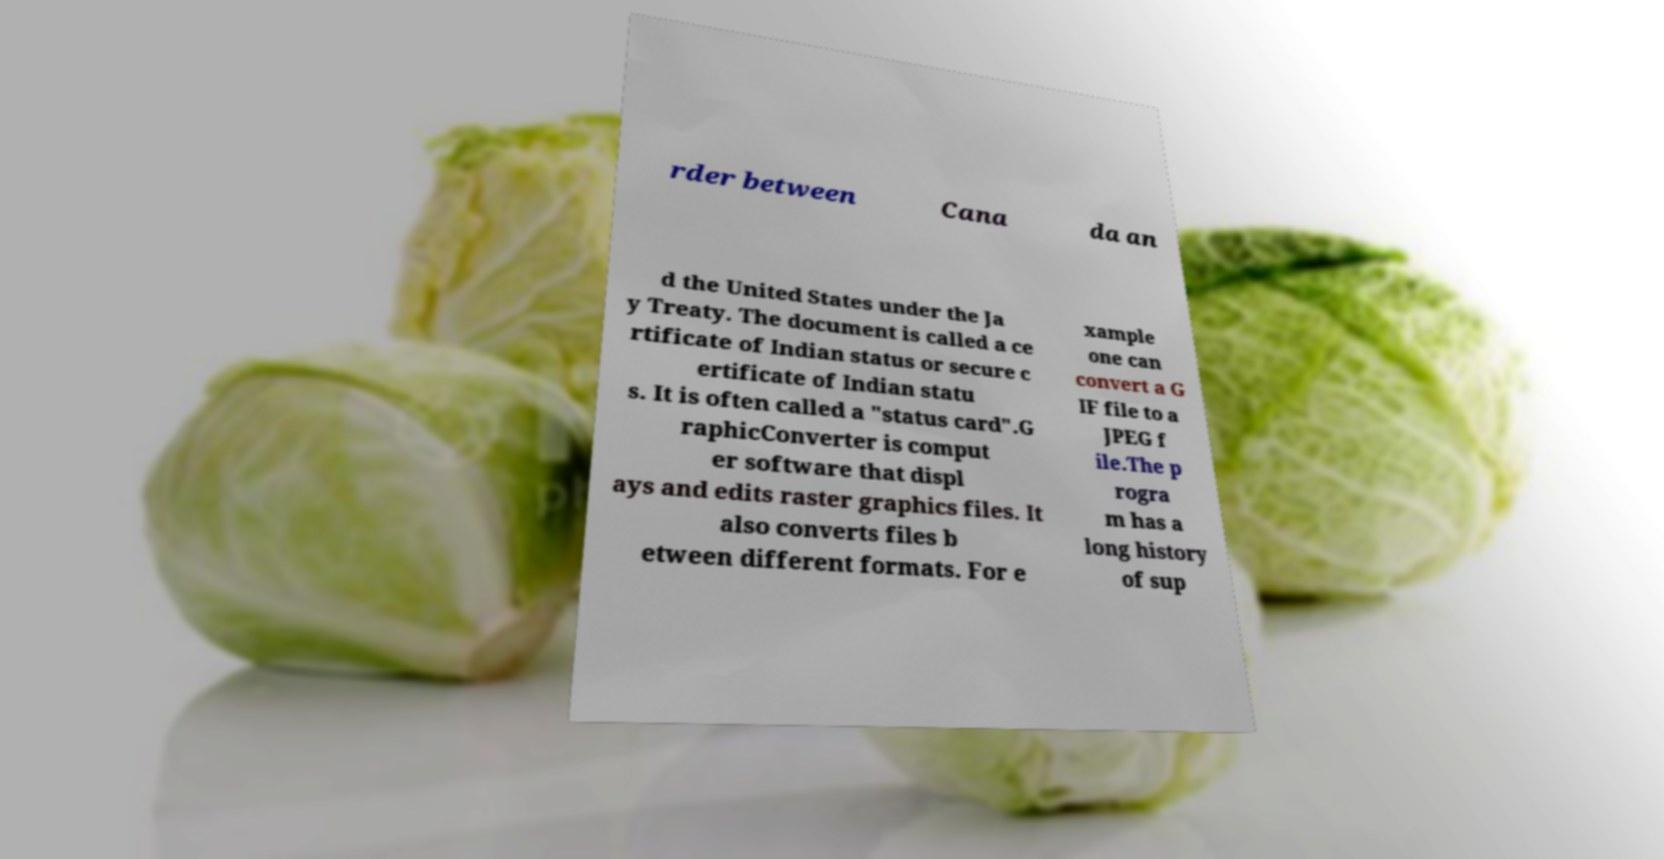Could you assist in decoding the text presented in this image and type it out clearly? rder between Cana da an d the United States under the Ja y Treaty. The document is called a ce rtificate of Indian status or secure c ertificate of Indian statu s. It is often called a "status card".G raphicConverter is comput er software that displ ays and edits raster graphics files. It also converts files b etween different formats. For e xample one can convert a G IF file to a JPEG f ile.The p rogra m has a long history of sup 